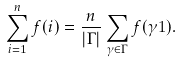<formula> <loc_0><loc_0><loc_500><loc_500>\sum _ { i = 1 } ^ { n } f ( i ) = \frac { n } { | \Gamma | } \sum _ { \gamma \in \Gamma } f ( \gamma 1 ) .</formula> 